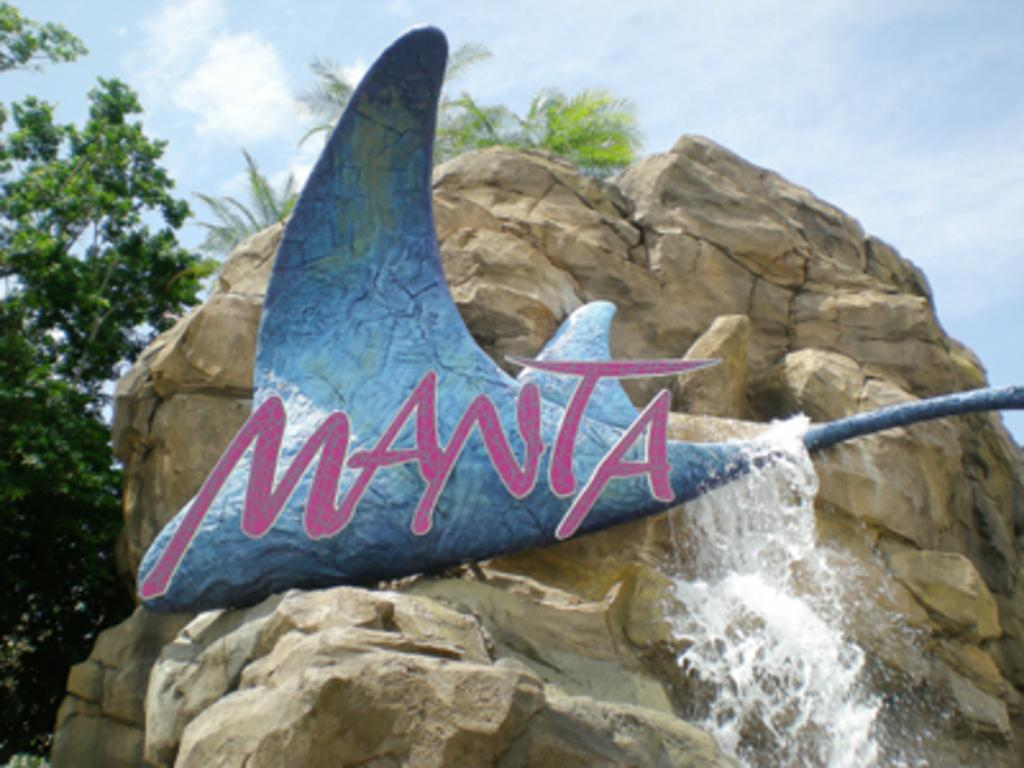What type of animal can be seen in the image? There is a fish in the image. What natural feature is present in the image? There is a waterfall in the image. Where is the waterfall located? The waterfall is on a rock. What can be seen in the background of the image? There are trees in the background of the image. What type of pets are present in the image? There are no pets visible in the image; it features a fish, a waterfall, and trees. Can you tell me the name of the minister in the image? There is no minister present in the image. 